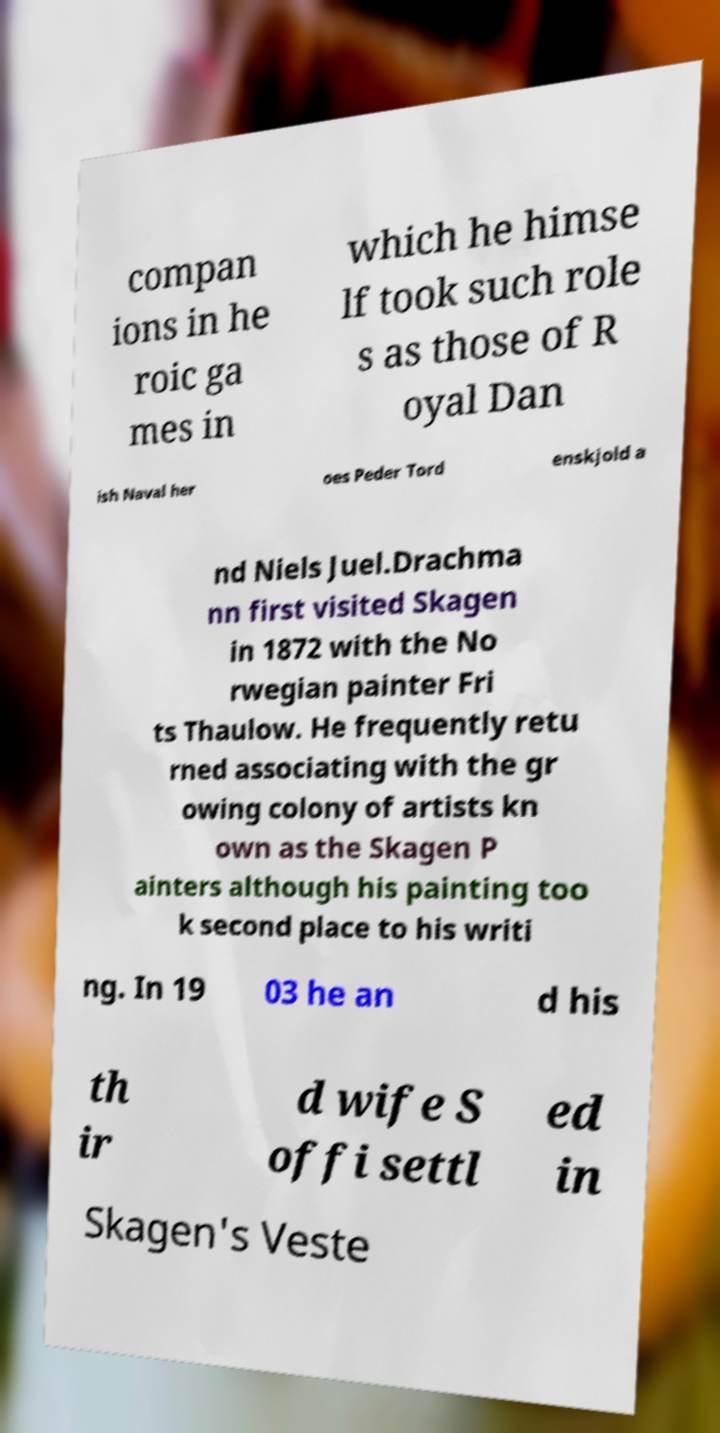I need the written content from this picture converted into text. Can you do that? compan ions in he roic ga mes in which he himse lf took such role s as those of R oyal Dan ish Naval her oes Peder Tord enskjold a nd Niels Juel.Drachma nn first visited Skagen in 1872 with the No rwegian painter Fri ts Thaulow. He frequently retu rned associating with the gr owing colony of artists kn own as the Skagen P ainters although his painting too k second place to his writi ng. In 19 03 he an d his th ir d wife S offi settl ed in Skagen's Veste 